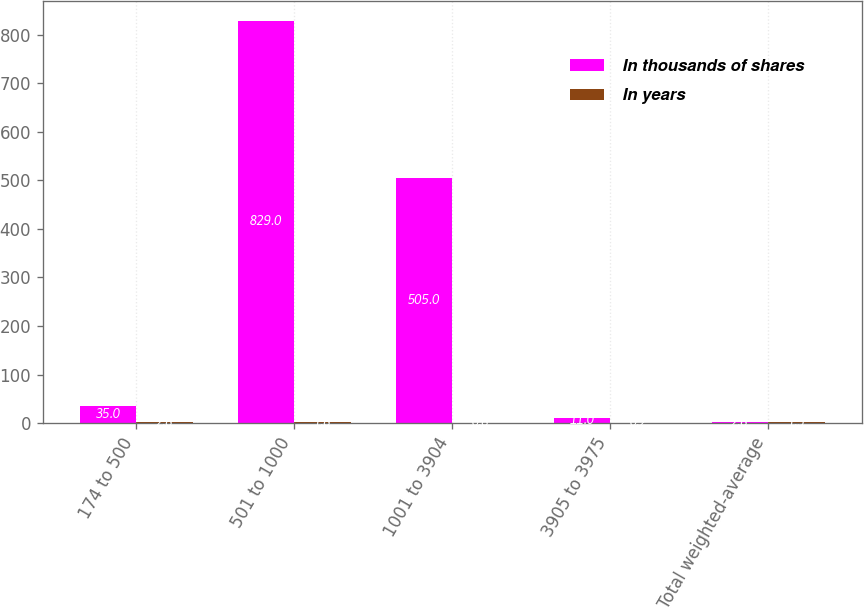Convert chart. <chart><loc_0><loc_0><loc_500><loc_500><stacked_bar_chart><ecel><fcel>174 to 500<fcel>501 to 1000<fcel>1001 to 3904<fcel>3905 to 3975<fcel>Total weighted-average<nl><fcel>In thousands of shares<fcel>35<fcel>829<fcel>505<fcel>11<fcel>2.8<nl><fcel>In years<fcel>2.8<fcel>1.8<fcel>0.8<fcel>0.2<fcel>1.5<nl></chart> 